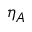Convert formula to latex. <formula><loc_0><loc_0><loc_500><loc_500>\eta _ { A }</formula> 